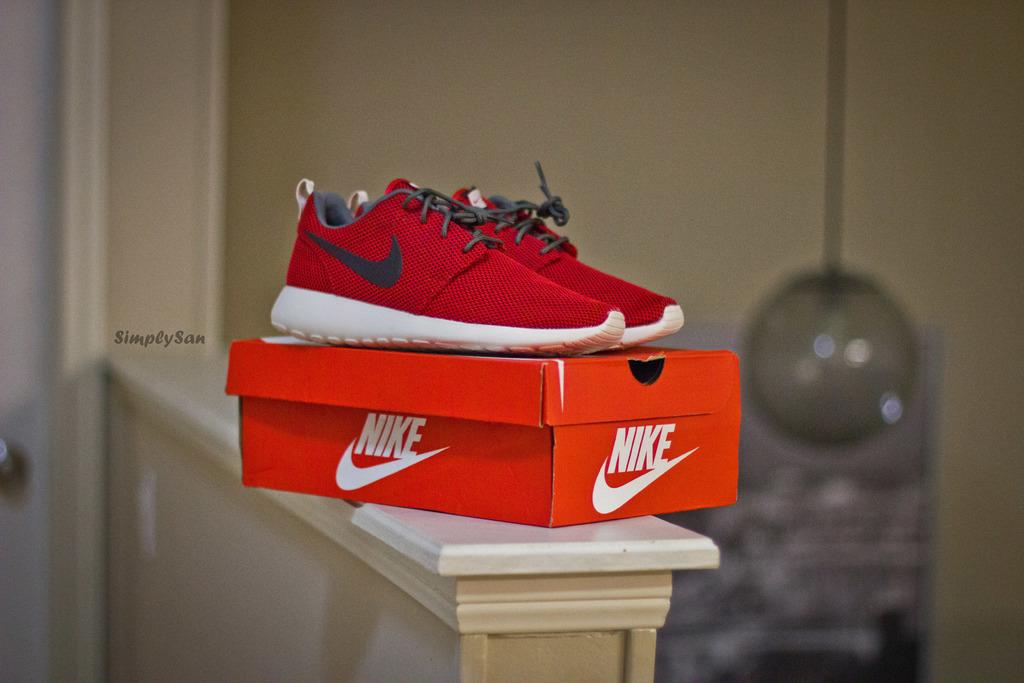What is the main subject in the center of the image? There are red shoes in the center of the image. Can you describe any other objects or features in the image? There is a box placed on the wall in the image. What type of rock is being used to trip people in the image? There is no rock or tripping depicted in the image; it features red shoes and a box on the wall. 